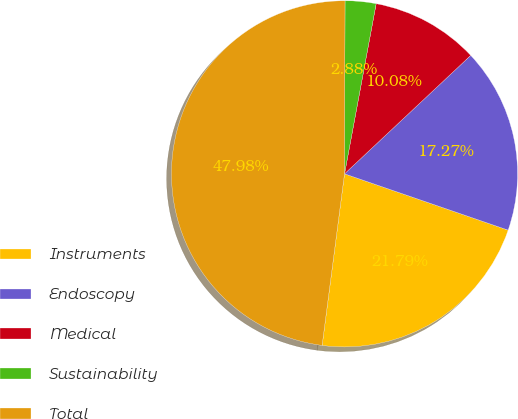Convert chart to OTSL. <chart><loc_0><loc_0><loc_500><loc_500><pie_chart><fcel>Instruments<fcel>Endoscopy<fcel>Medical<fcel>Sustainability<fcel>Total<nl><fcel>21.79%<fcel>17.27%<fcel>10.08%<fcel>2.88%<fcel>47.98%<nl></chart> 